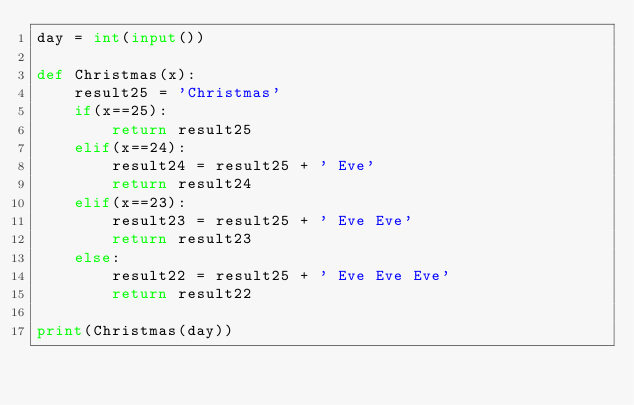<code> <loc_0><loc_0><loc_500><loc_500><_Python_>day = int(input())

def Christmas(x):
    result25 = 'Christmas'
    if(x==25):
        return result25
    elif(x==24):
        result24 = result25 + ' Eve'
        return result24
    elif(x==23):
        result23 = result25 + ' Eve Eve'
        return result23
    else:
        result22 = result25 + ' Eve Eve Eve'
        return result22

print(Christmas(day))</code> 